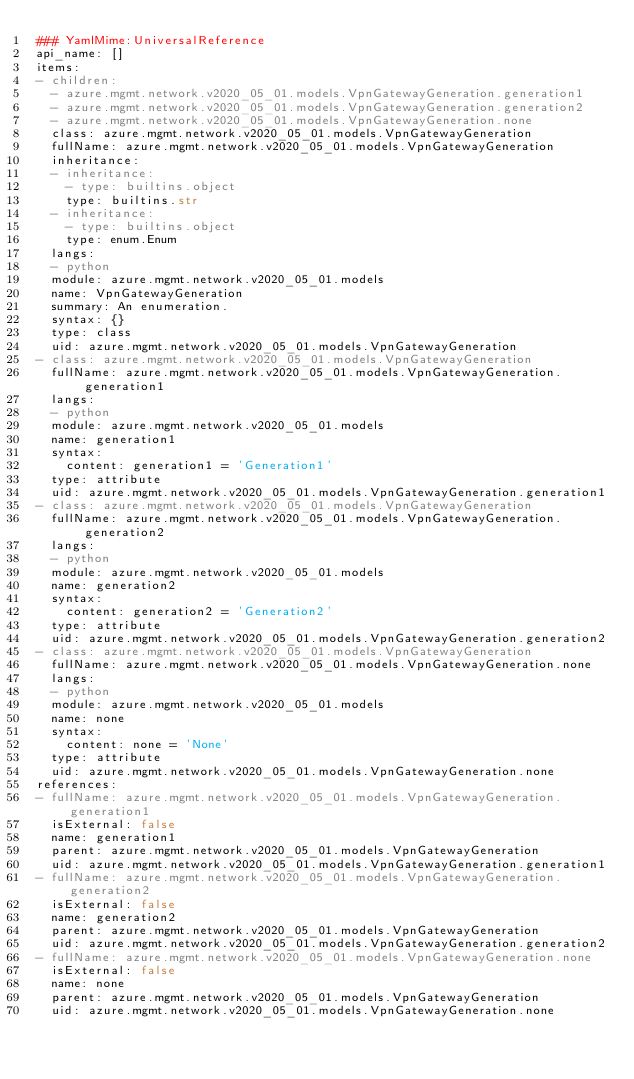<code> <loc_0><loc_0><loc_500><loc_500><_YAML_>### YamlMime:UniversalReference
api_name: []
items:
- children:
  - azure.mgmt.network.v2020_05_01.models.VpnGatewayGeneration.generation1
  - azure.mgmt.network.v2020_05_01.models.VpnGatewayGeneration.generation2
  - azure.mgmt.network.v2020_05_01.models.VpnGatewayGeneration.none
  class: azure.mgmt.network.v2020_05_01.models.VpnGatewayGeneration
  fullName: azure.mgmt.network.v2020_05_01.models.VpnGatewayGeneration
  inheritance:
  - inheritance:
    - type: builtins.object
    type: builtins.str
  - inheritance:
    - type: builtins.object
    type: enum.Enum
  langs:
  - python
  module: azure.mgmt.network.v2020_05_01.models
  name: VpnGatewayGeneration
  summary: An enumeration.
  syntax: {}
  type: class
  uid: azure.mgmt.network.v2020_05_01.models.VpnGatewayGeneration
- class: azure.mgmt.network.v2020_05_01.models.VpnGatewayGeneration
  fullName: azure.mgmt.network.v2020_05_01.models.VpnGatewayGeneration.generation1
  langs:
  - python
  module: azure.mgmt.network.v2020_05_01.models
  name: generation1
  syntax:
    content: generation1 = 'Generation1'
  type: attribute
  uid: azure.mgmt.network.v2020_05_01.models.VpnGatewayGeneration.generation1
- class: azure.mgmt.network.v2020_05_01.models.VpnGatewayGeneration
  fullName: azure.mgmt.network.v2020_05_01.models.VpnGatewayGeneration.generation2
  langs:
  - python
  module: azure.mgmt.network.v2020_05_01.models
  name: generation2
  syntax:
    content: generation2 = 'Generation2'
  type: attribute
  uid: azure.mgmt.network.v2020_05_01.models.VpnGatewayGeneration.generation2
- class: azure.mgmt.network.v2020_05_01.models.VpnGatewayGeneration
  fullName: azure.mgmt.network.v2020_05_01.models.VpnGatewayGeneration.none
  langs:
  - python
  module: azure.mgmt.network.v2020_05_01.models
  name: none
  syntax:
    content: none = 'None'
  type: attribute
  uid: azure.mgmt.network.v2020_05_01.models.VpnGatewayGeneration.none
references:
- fullName: azure.mgmt.network.v2020_05_01.models.VpnGatewayGeneration.generation1
  isExternal: false
  name: generation1
  parent: azure.mgmt.network.v2020_05_01.models.VpnGatewayGeneration
  uid: azure.mgmt.network.v2020_05_01.models.VpnGatewayGeneration.generation1
- fullName: azure.mgmt.network.v2020_05_01.models.VpnGatewayGeneration.generation2
  isExternal: false
  name: generation2
  parent: azure.mgmt.network.v2020_05_01.models.VpnGatewayGeneration
  uid: azure.mgmt.network.v2020_05_01.models.VpnGatewayGeneration.generation2
- fullName: azure.mgmt.network.v2020_05_01.models.VpnGatewayGeneration.none
  isExternal: false
  name: none
  parent: azure.mgmt.network.v2020_05_01.models.VpnGatewayGeneration
  uid: azure.mgmt.network.v2020_05_01.models.VpnGatewayGeneration.none
</code> 